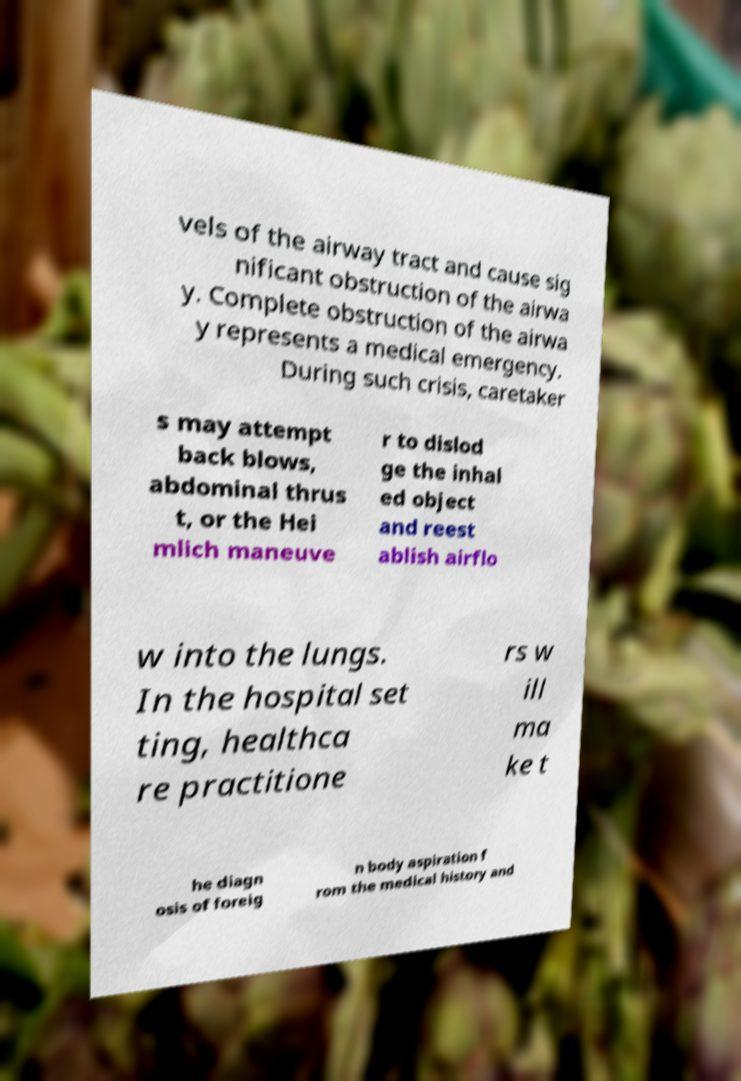For documentation purposes, I need the text within this image transcribed. Could you provide that? vels of the airway tract and cause sig nificant obstruction of the airwa y. Complete obstruction of the airwa y represents a medical emergency. During such crisis, caretaker s may attempt back blows, abdominal thrus t, or the Hei mlich maneuve r to dislod ge the inhal ed object and reest ablish airflo w into the lungs. In the hospital set ting, healthca re practitione rs w ill ma ke t he diagn osis of foreig n body aspiration f rom the medical history and 